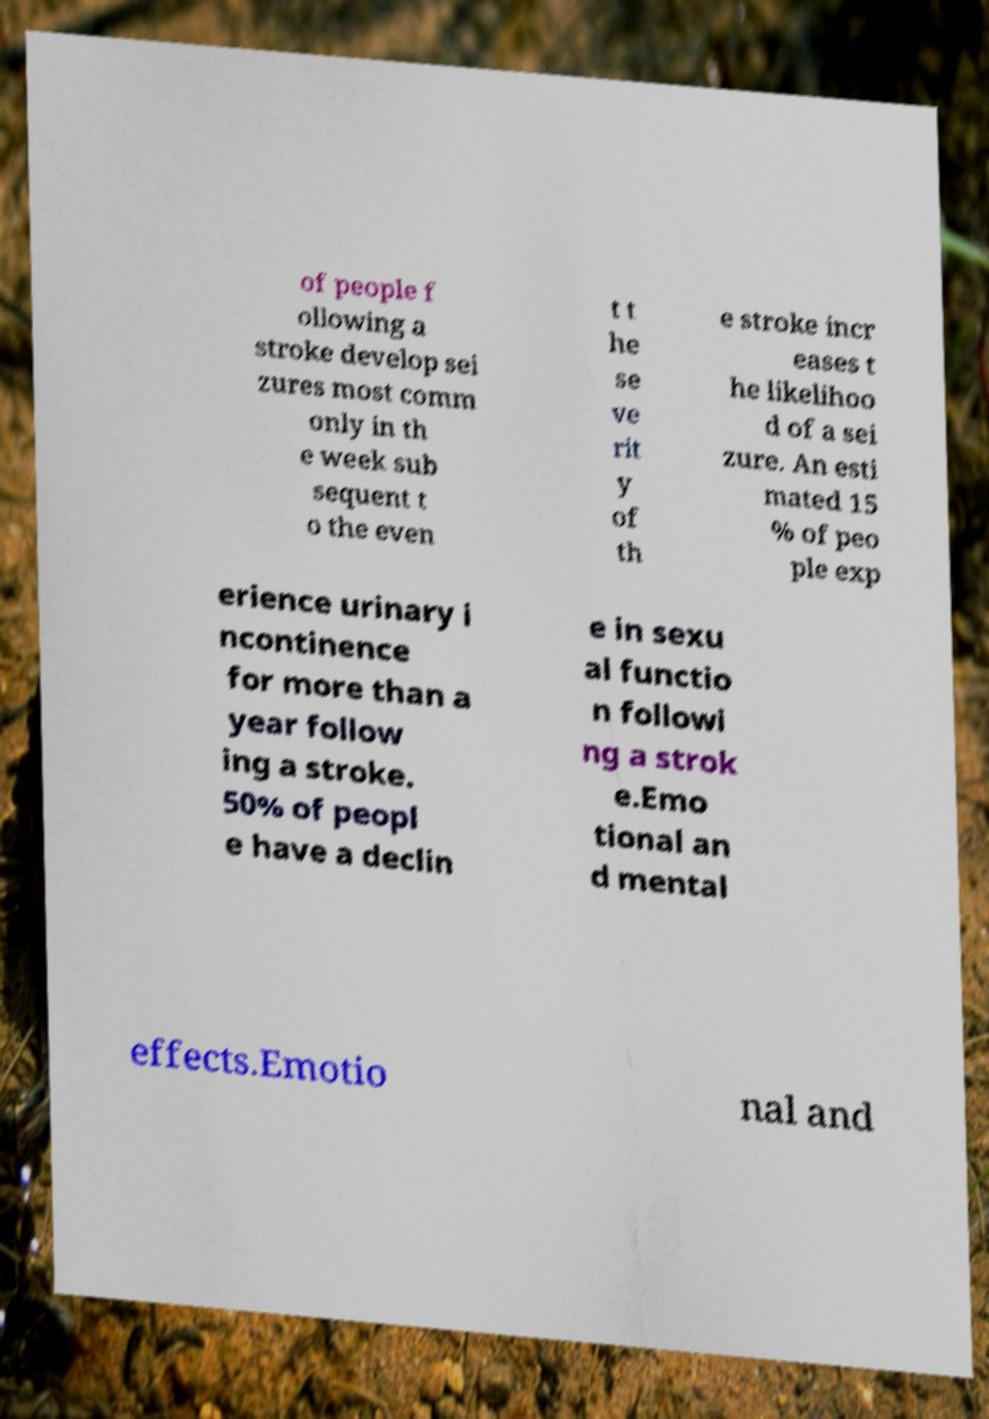I need the written content from this picture converted into text. Can you do that? of people f ollowing a stroke develop sei zures most comm only in th e week sub sequent t o the even t t he se ve rit y of th e stroke incr eases t he likelihoo d of a sei zure. An esti mated 15 % of peo ple exp erience urinary i ncontinence for more than a year follow ing a stroke. 50% of peopl e have a declin e in sexu al functio n followi ng a strok e.Emo tional an d mental effects.Emotio nal and 